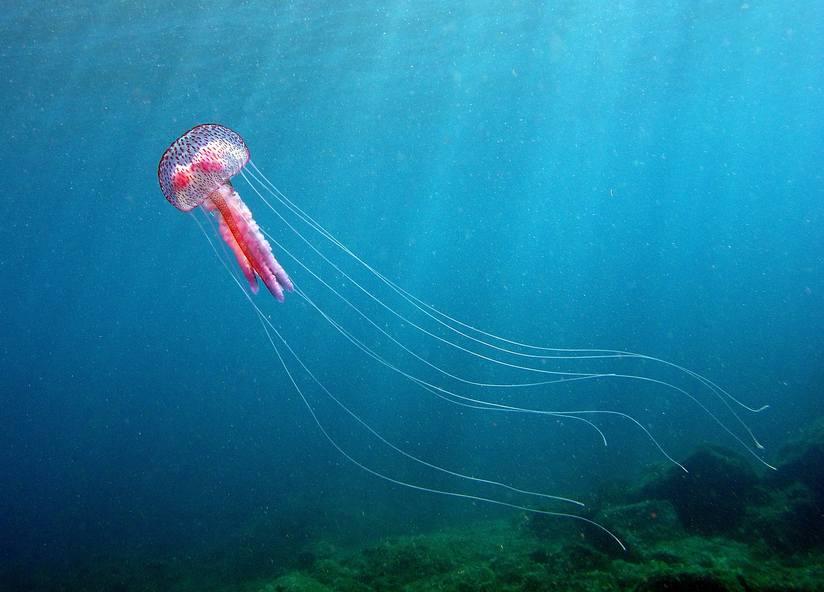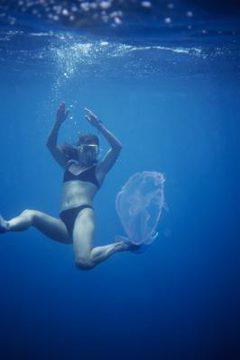The first image is the image on the left, the second image is the image on the right. Examine the images to the left and right. Is the description "The jellyfish in the right image are translucent." accurate? Answer yes or no. Yes. The first image is the image on the left, the second image is the image on the right. Assess this claim about the two images: "The jellyfish in the left and right images are generally the same color, and no single image contains more than two jellyfish.". Correct or not? Answer yes or no. No. 